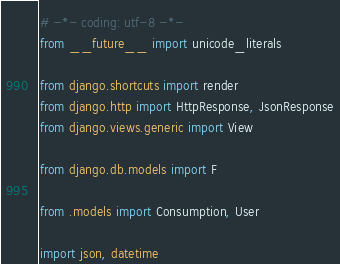Convert code to text. <code><loc_0><loc_0><loc_500><loc_500><_Python_># -*- coding: utf-8 -*-
from __future__ import unicode_literals

from django.shortcuts import render
from django.http import HttpResponse, JsonResponse
from django.views.generic import View

from django.db.models import F

from .models import Consumption, User

import json, datetime

</code> 